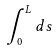Convert formula to latex. <formula><loc_0><loc_0><loc_500><loc_500>\int _ { 0 } ^ { L } d s</formula> 